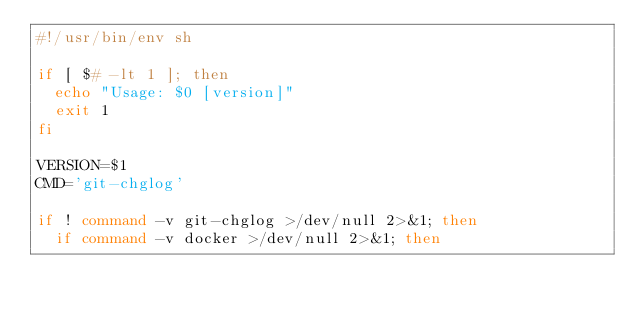<code> <loc_0><loc_0><loc_500><loc_500><_Bash_>#!/usr/bin/env sh

if [ $# -lt 1 ]; then
  echo "Usage: $0 [version]"
  exit 1
fi

VERSION=$1
CMD='git-chglog'

if ! command -v git-chglog >/dev/null 2>&1; then
  if command -v docker >/dev/null 2>&1; then</code> 